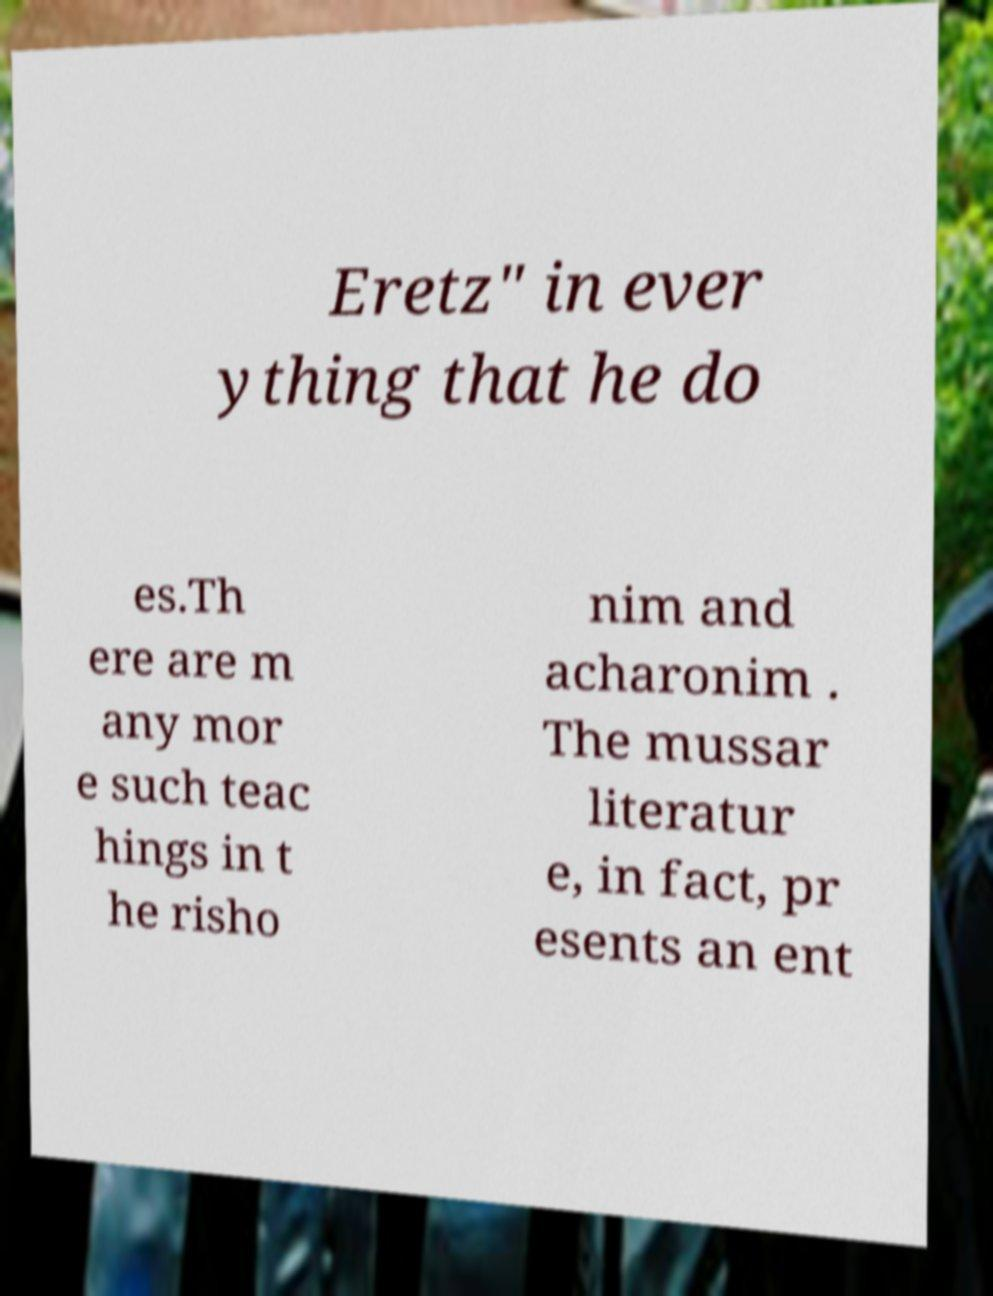Please identify and transcribe the text found in this image. Eretz" in ever ything that he do es.Th ere are m any mor e such teac hings in t he risho nim and acharonim . The mussar literatur e, in fact, pr esents an ent 